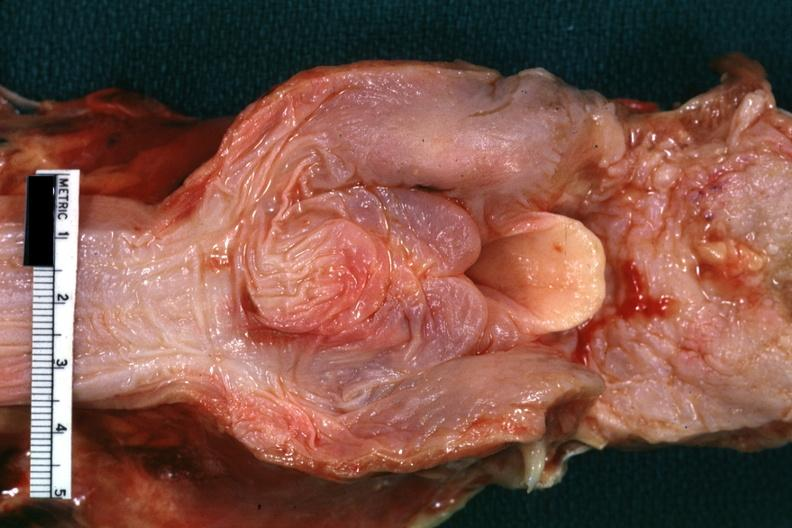where is this?
Answer the question using a single word or phrase. Oral 